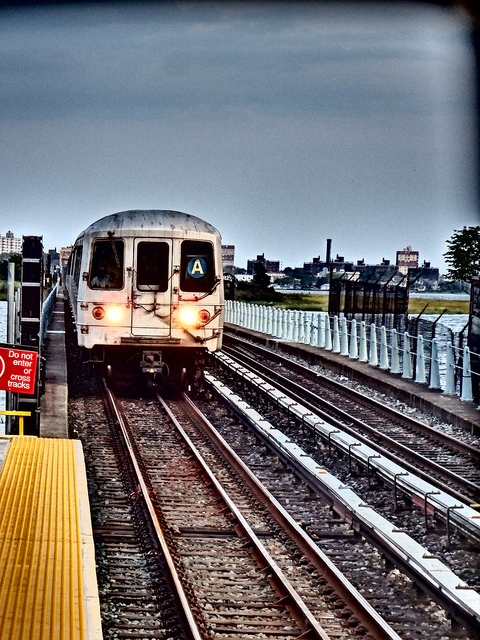Please extract the text content from this image. A Do not or tracks Crost enter 